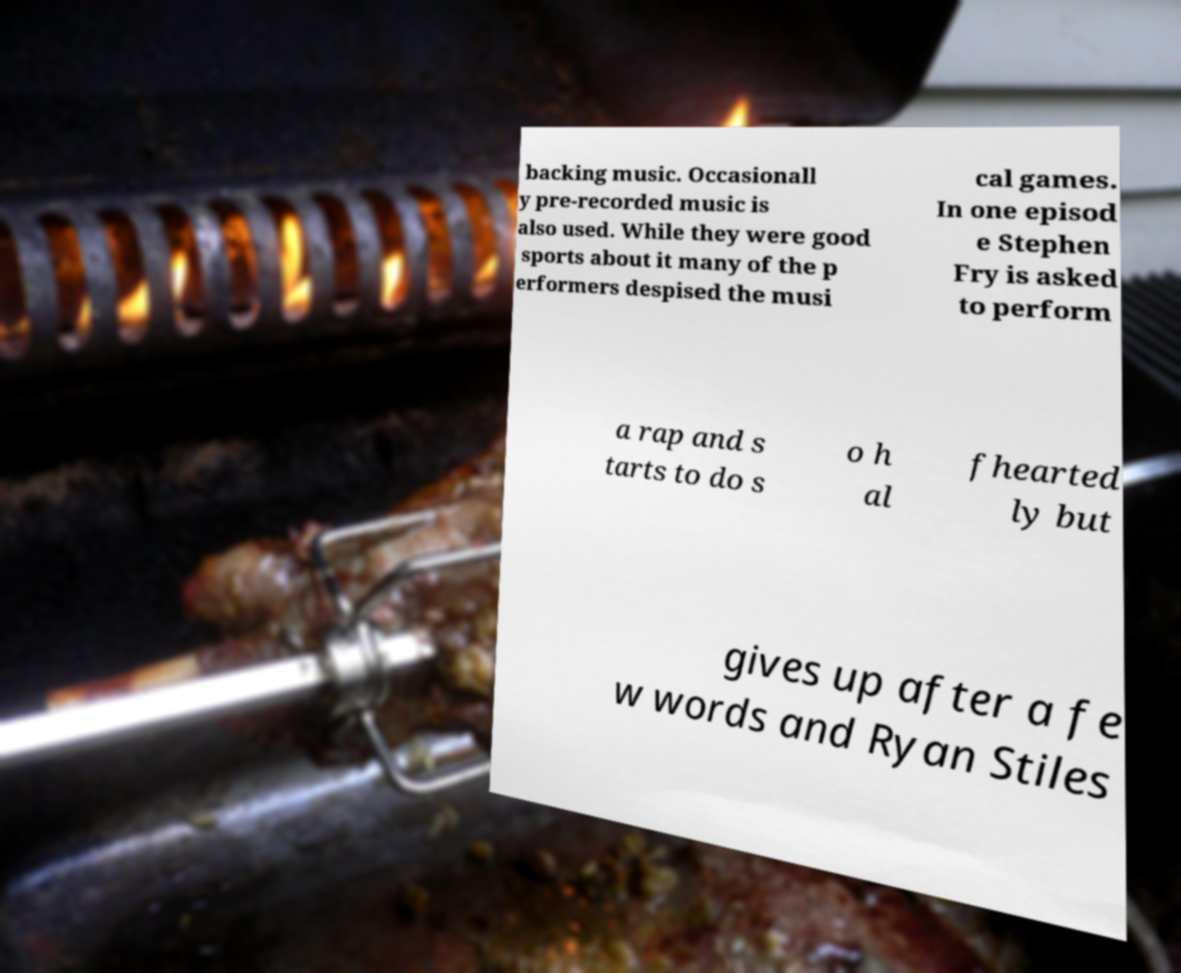Can you accurately transcribe the text from the provided image for me? backing music. Occasionall y pre-recorded music is also used. While they were good sports about it many of the p erformers despised the musi cal games. In one episod e Stephen Fry is asked to perform a rap and s tarts to do s o h al fhearted ly but gives up after a fe w words and Ryan Stiles 